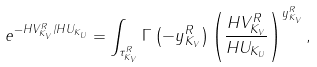Convert formula to latex. <formula><loc_0><loc_0><loc_500><loc_500>e ^ { - H V _ { K _ { V } } ^ { R } / H U _ { K _ { U } } } = \int _ { \tau _ { K _ { V } } ^ { R } } \Gamma \left ( - y _ { K _ { V } } ^ { R } \right ) \left ( \frac { H V _ { K _ { V } } ^ { R } } { H U _ { K _ { U } } } \right ) ^ { y _ { K _ { V } } ^ { R } } ,</formula> 